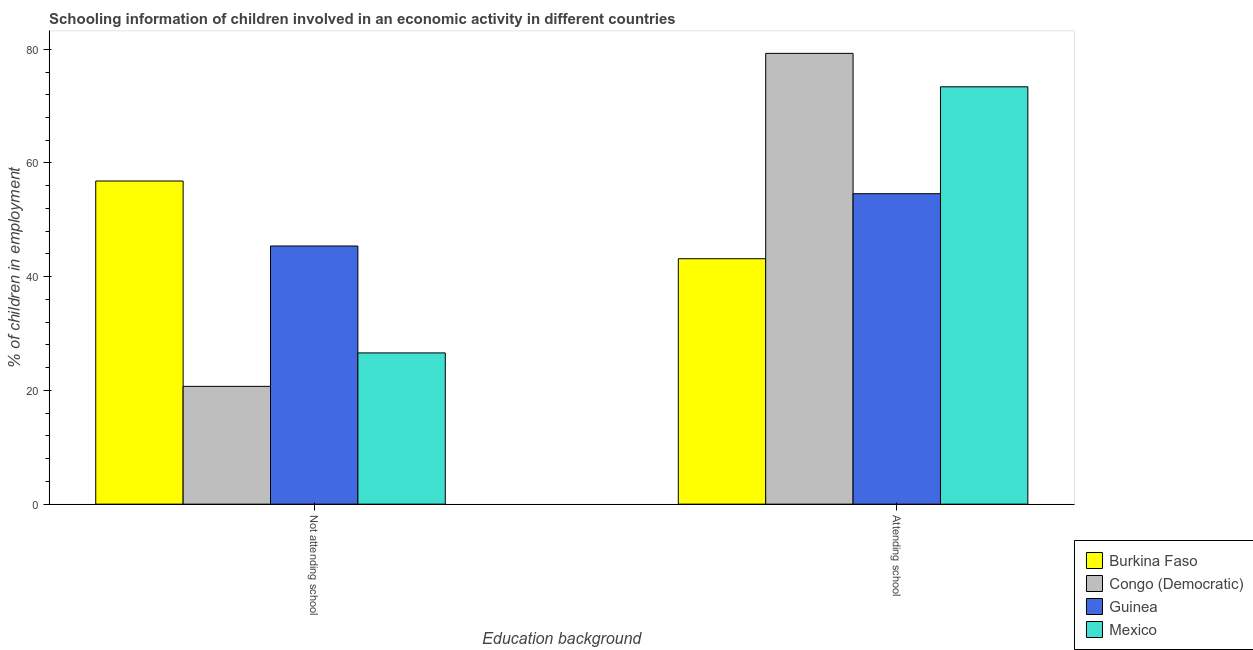Are the number of bars on each tick of the X-axis equal?
Keep it short and to the point. Yes. How many bars are there on the 2nd tick from the left?
Provide a short and direct response. 4. How many bars are there on the 2nd tick from the right?
Ensure brevity in your answer.  4. What is the label of the 2nd group of bars from the left?
Give a very brief answer. Attending school. What is the percentage of employed children who are attending school in Burkina Faso?
Give a very brief answer. 43.17. Across all countries, what is the maximum percentage of employed children who are not attending school?
Your response must be concise. 56.83. Across all countries, what is the minimum percentage of employed children who are not attending school?
Your response must be concise. 20.72. In which country was the percentage of employed children who are not attending school maximum?
Your response must be concise. Burkina Faso. In which country was the percentage of employed children who are not attending school minimum?
Ensure brevity in your answer.  Congo (Democratic). What is the total percentage of employed children who are attending school in the graph?
Keep it short and to the point. 250.45. What is the difference between the percentage of employed children who are attending school in Mexico and that in Burkina Faso?
Keep it short and to the point. 30.23. What is the difference between the percentage of employed children who are not attending school in Mexico and the percentage of employed children who are attending school in Guinea?
Provide a short and direct response. -28. What is the average percentage of employed children who are attending school per country?
Your answer should be compact. 62.61. What is the difference between the percentage of employed children who are attending school and percentage of employed children who are not attending school in Guinea?
Give a very brief answer. 9.2. What is the ratio of the percentage of employed children who are not attending school in Guinea to that in Congo (Democratic)?
Make the answer very short. 2.19. Is the percentage of employed children who are attending school in Mexico less than that in Guinea?
Provide a succinct answer. No. In how many countries, is the percentage of employed children who are attending school greater than the average percentage of employed children who are attending school taken over all countries?
Provide a succinct answer. 2. What does the 2nd bar from the left in Not attending school represents?
Make the answer very short. Congo (Democratic). What does the 4th bar from the right in Not attending school represents?
Provide a short and direct response. Burkina Faso. What is the difference between two consecutive major ticks on the Y-axis?
Provide a short and direct response. 20. Are the values on the major ticks of Y-axis written in scientific E-notation?
Provide a succinct answer. No. Where does the legend appear in the graph?
Give a very brief answer. Bottom right. What is the title of the graph?
Your answer should be compact. Schooling information of children involved in an economic activity in different countries. Does "Romania" appear as one of the legend labels in the graph?
Your response must be concise. No. What is the label or title of the X-axis?
Provide a short and direct response. Education background. What is the label or title of the Y-axis?
Keep it short and to the point. % of children in employment. What is the % of children in employment of Burkina Faso in Not attending school?
Make the answer very short. 56.83. What is the % of children in employment of Congo (Democratic) in Not attending school?
Make the answer very short. 20.72. What is the % of children in employment of Guinea in Not attending school?
Keep it short and to the point. 45.4. What is the % of children in employment of Mexico in Not attending school?
Your answer should be compact. 26.6. What is the % of children in employment in Burkina Faso in Attending school?
Your answer should be compact. 43.17. What is the % of children in employment of Congo (Democratic) in Attending school?
Your response must be concise. 79.28. What is the % of children in employment in Guinea in Attending school?
Offer a terse response. 54.6. What is the % of children in employment of Mexico in Attending school?
Give a very brief answer. 73.4. Across all Education background, what is the maximum % of children in employment of Burkina Faso?
Offer a terse response. 56.83. Across all Education background, what is the maximum % of children in employment of Congo (Democratic)?
Provide a succinct answer. 79.28. Across all Education background, what is the maximum % of children in employment in Guinea?
Make the answer very short. 54.6. Across all Education background, what is the maximum % of children in employment of Mexico?
Your answer should be compact. 73.4. Across all Education background, what is the minimum % of children in employment of Burkina Faso?
Make the answer very short. 43.17. Across all Education background, what is the minimum % of children in employment of Congo (Democratic)?
Give a very brief answer. 20.72. Across all Education background, what is the minimum % of children in employment of Guinea?
Offer a terse response. 45.4. Across all Education background, what is the minimum % of children in employment in Mexico?
Provide a succinct answer. 26.6. What is the total % of children in employment in Burkina Faso in the graph?
Offer a very short reply. 100. What is the total % of children in employment in Congo (Democratic) in the graph?
Offer a terse response. 100. What is the total % of children in employment of Mexico in the graph?
Your answer should be very brief. 100. What is the difference between the % of children in employment of Burkina Faso in Not attending school and that in Attending school?
Your answer should be compact. 13.67. What is the difference between the % of children in employment in Congo (Democratic) in Not attending school and that in Attending school?
Give a very brief answer. -58.56. What is the difference between the % of children in employment in Guinea in Not attending school and that in Attending school?
Provide a short and direct response. -9.2. What is the difference between the % of children in employment in Mexico in Not attending school and that in Attending school?
Ensure brevity in your answer.  -46.8. What is the difference between the % of children in employment in Burkina Faso in Not attending school and the % of children in employment in Congo (Democratic) in Attending school?
Give a very brief answer. -22.45. What is the difference between the % of children in employment in Burkina Faso in Not attending school and the % of children in employment in Guinea in Attending school?
Your response must be concise. 2.23. What is the difference between the % of children in employment in Burkina Faso in Not attending school and the % of children in employment in Mexico in Attending school?
Offer a terse response. -16.57. What is the difference between the % of children in employment in Congo (Democratic) in Not attending school and the % of children in employment in Guinea in Attending school?
Make the answer very short. -33.88. What is the difference between the % of children in employment of Congo (Democratic) in Not attending school and the % of children in employment of Mexico in Attending school?
Offer a very short reply. -52.68. What is the average % of children in employment in Burkina Faso per Education background?
Make the answer very short. 50. What is the average % of children in employment of Congo (Democratic) per Education background?
Provide a succinct answer. 50. What is the average % of children in employment in Mexico per Education background?
Your response must be concise. 50. What is the difference between the % of children in employment in Burkina Faso and % of children in employment in Congo (Democratic) in Not attending school?
Ensure brevity in your answer.  36.11. What is the difference between the % of children in employment in Burkina Faso and % of children in employment in Guinea in Not attending school?
Provide a succinct answer. 11.43. What is the difference between the % of children in employment of Burkina Faso and % of children in employment of Mexico in Not attending school?
Your answer should be very brief. 30.23. What is the difference between the % of children in employment of Congo (Democratic) and % of children in employment of Guinea in Not attending school?
Provide a succinct answer. -24.68. What is the difference between the % of children in employment in Congo (Democratic) and % of children in employment in Mexico in Not attending school?
Your answer should be compact. -5.88. What is the difference between the % of children in employment of Guinea and % of children in employment of Mexico in Not attending school?
Keep it short and to the point. 18.8. What is the difference between the % of children in employment in Burkina Faso and % of children in employment in Congo (Democratic) in Attending school?
Your response must be concise. -36.11. What is the difference between the % of children in employment of Burkina Faso and % of children in employment of Guinea in Attending school?
Keep it short and to the point. -11.43. What is the difference between the % of children in employment in Burkina Faso and % of children in employment in Mexico in Attending school?
Your response must be concise. -30.23. What is the difference between the % of children in employment of Congo (Democratic) and % of children in employment of Guinea in Attending school?
Your answer should be very brief. 24.68. What is the difference between the % of children in employment in Congo (Democratic) and % of children in employment in Mexico in Attending school?
Make the answer very short. 5.88. What is the difference between the % of children in employment in Guinea and % of children in employment in Mexico in Attending school?
Give a very brief answer. -18.8. What is the ratio of the % of children in employment in Burkina Faso in Not attending school to that in Attending school?
Ensure brevity in your answer.  1.32. What is the ratio of the % of children in employment of Congo (Democratic) in Not attending school to that in Attending school?
Keep it short and to the point. 0.26. What is the ratio of the % of children in employment of Guinea in Not attending school to that in Attending school?
Your answer should be very brief. 0.83. What is the ratio of the % of children in employment of Mexico in Not attending school to that in Attending school?
Your answer should be compact. 0.36. What is the difference between the highest and the second highest % of children in employment in Burkina Faso?
Offer a terse response. 13.67. What is the difference between the highest and the second highest % of children in employment of Congo (Democratic)?
Give a very brief answer. 58.56. What is the difference between the highest and the second highest % of children in employment in Mexico?
Your response must be concise. 46.8. What is the difference between the highest and the lowest % of children in employment in Burkina Faso?
Offer a terse response. 13.67. What is the difference between the highest and the lowest % of children in employment of Congo (Democratic)?
Your answer should be very brief. 58.56. What is the difference between the highest and the lowest % of children in employment of Mexico?
Your answer should be compact. 46.8. 